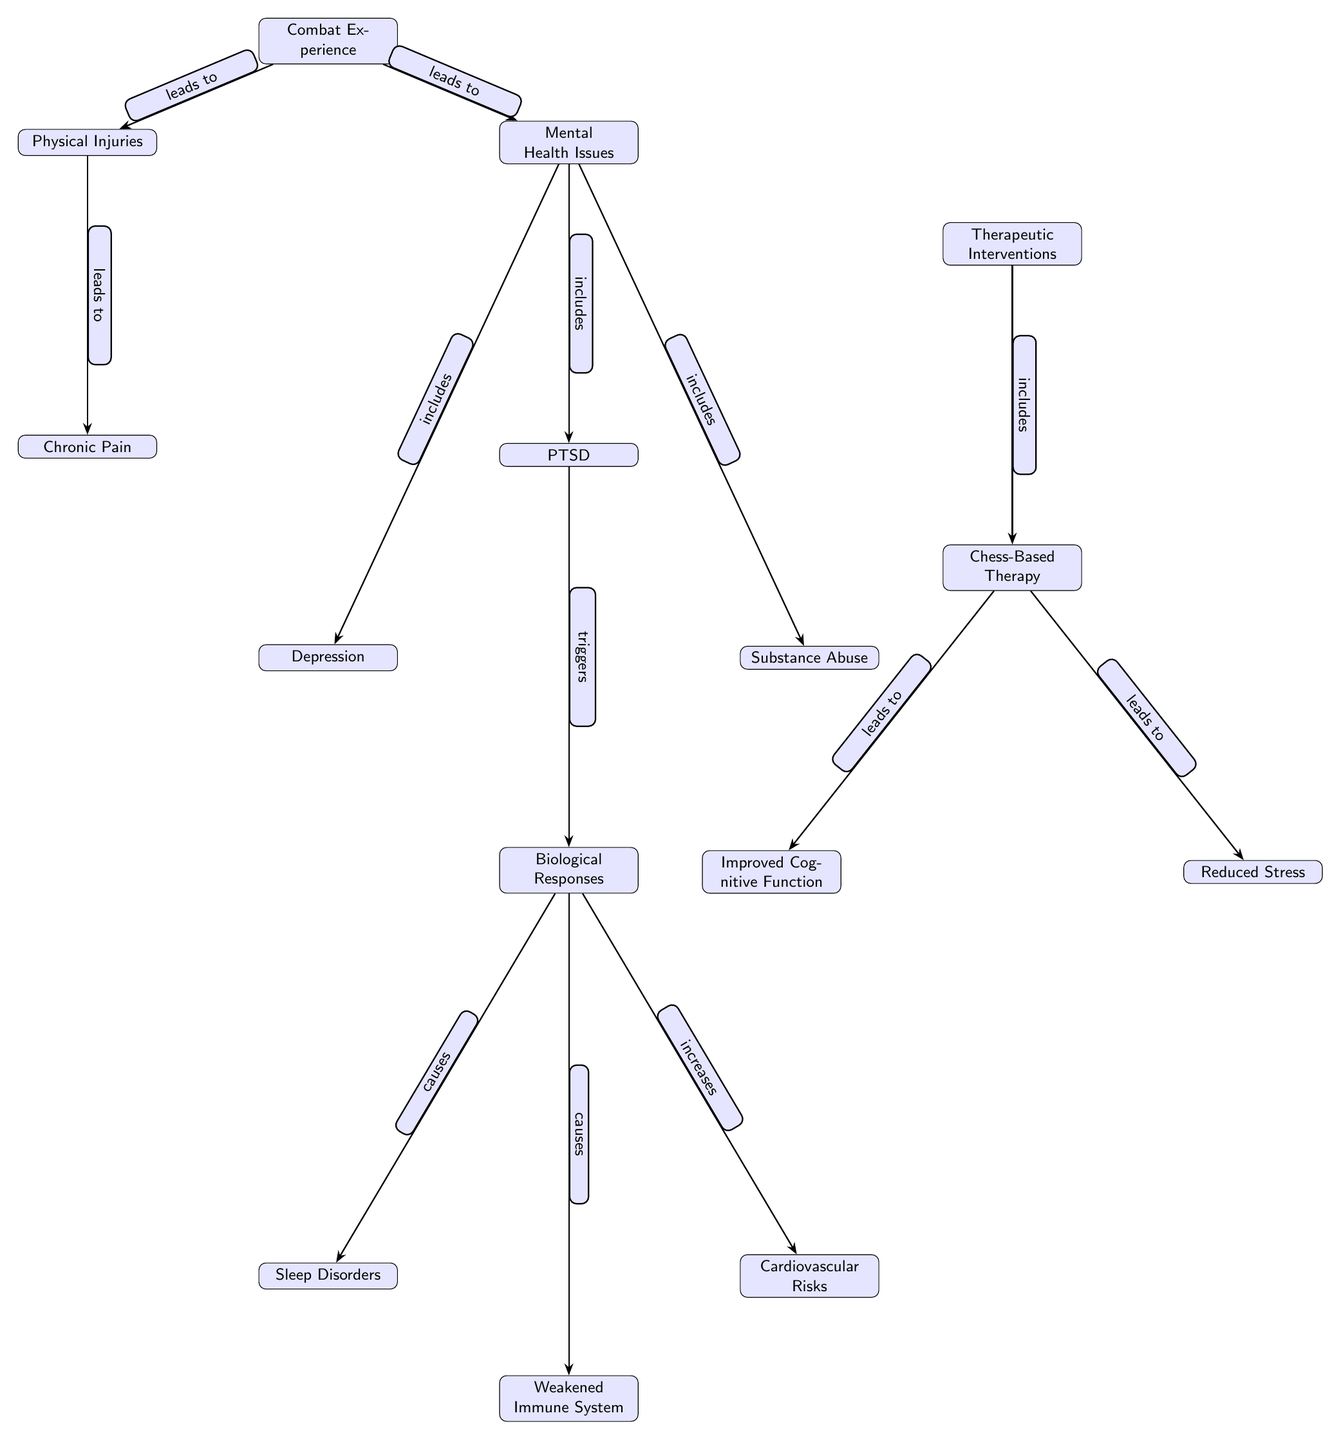What is the starting point of the diagram? The starting point of the diagram is "Combat Experience," which is the first node at the top of the diagram indicating the initial factor influencing both physical and mental health in veterans.
Answer: Combat Experience How many dimensions of mental health issues are represented? The diagram shows three types of mental health issues stemming from "Combat Experience": PTSD, Depression, and Substance Abuse, evidenced by three nodes branching off the "Mental Health Issues" node.
Answer: Three What does PTSD trigger in the diagram? "PTSD" is shown as leading into the "Biological Responses" node, which indicates that PTSD is a factor that triggers various biological responses in the body.
Answer: Biological Responses What are the biological outcomes linked to "Biological Responses"? The diagram illustrates three biological outcomes linked to "Biological Responses": "Sleep Disorders," "Weakened Immune System," and "Cardiovascular Risks," as they are all directly connected below the "Biological Responses" node.
Answer: Sleep Disorders, Weakened Immune System, Cardiovascular Risks What therapeutic intervention is specifically mentioned in the diagram? The diagram highlights "Chess-Based Therapy" as the therapeutic intervention included under "Therapeutic Interventions," indicating a specific method for addressing the issues depicted in the diagram.
Answer: Chess-Based Therapy How does chess-based therapy affect cognitive function? According to the diagram, "Chess-Based Therapy" leads to "Improved Cognitive Function," suggesting a positive outcome of implementing this therapy to enhance cognitive abilities in veterans.
Answer: Improved Cognitive Function Which physical consequence is linked to physical injuries? The diagram indicates that "Physical Injuries" lead to "Chronic Pain," representing the physical consequence of injuries sustained during combat experiences.
Answer: Chronic Pain What is the relationship between "Chess-Based Therapy" and "Reduced Stress"? The diagram shows that "Chess-Based Therapy" leads to "Reduced Stress," suggesting that engaging in this therapy can help alleviate stress levels among veterans.
Answer: Reduced Stress Which health issue does lead to substance abuse according to the diagram? The diagram indicates that "PTSD" includes "Substance Abuse," meaning that the presence of PTSD can lead to an increase in substance abuse issues among veterans.
Answer: Substance Abuse 